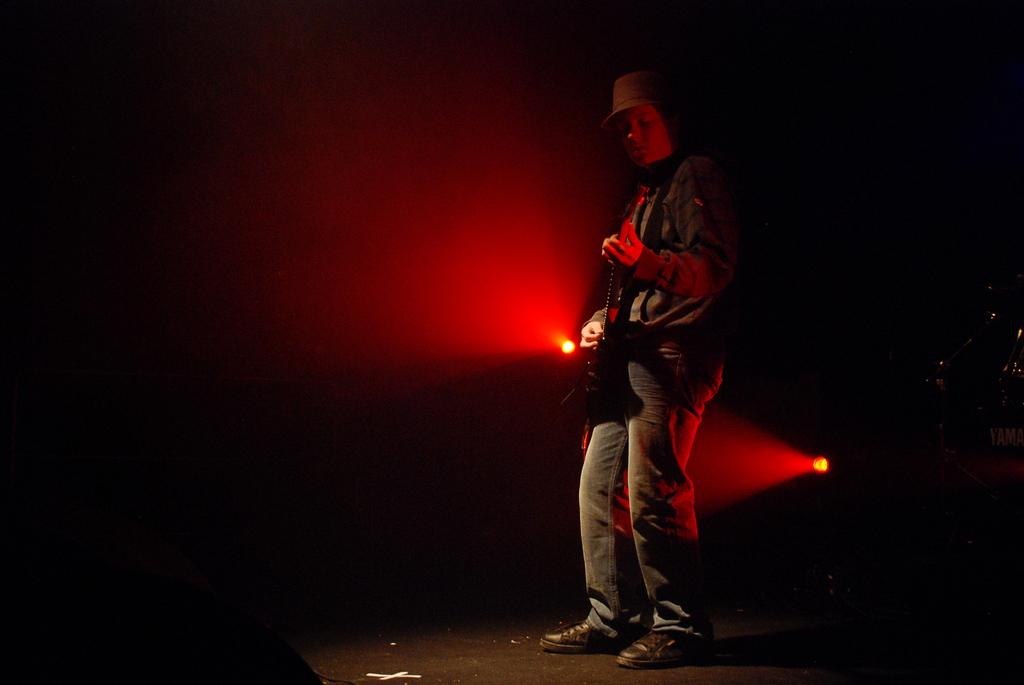What is the person in the image doing? The person in the image is playing a guitar. What can be seen on the person's head? The person is wearing a cap. What color are the lights present in the image? The red lights are present in the image. What type of advice is the minister giving in the image? There is no minister present in the image, so no advice can be given. Is the person in the image participating in a war? There is no indication of war or any conflict in the image; the person is simply playing a guitar. 